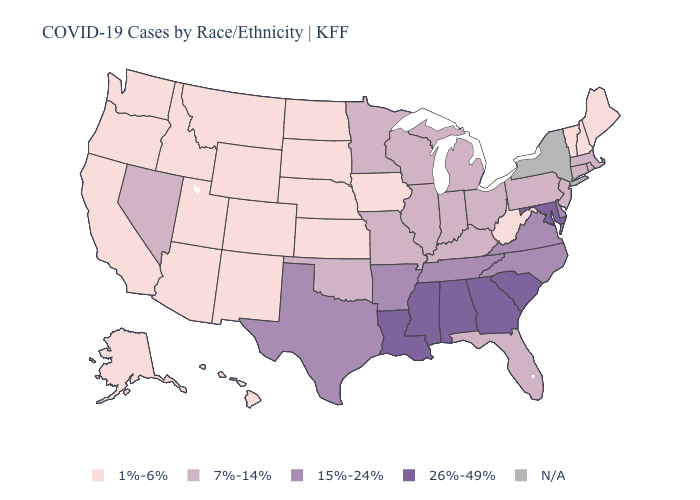What is the lowest value in the Northeast?
Concise answer only. 1%-6%. Does the map have missing data?
Give a very brief answer. Yes. Name the states that have a value in the range 26%-49%?
Quick response, please. Alabama, Georgia, Louisiana, Maryland, Mississippi, South Carolina. Name the states that have a value in the range 7%-14%?
Be succinct. Connecticut, Florida, Illinois, Indiana, Kentucky, Massachusetts, Michigan, Minnesota, Missouri, Nevada, New Jersey, Ohio, Oklahoma, Pennsylvania, Rhode Island, Wisconsin. Name the states that have a value in the range 15%-24%?
Answer briefly. Arkansas, Delaware, North Carolina, Tennessee, Texas, Virginia. Name the states that have a value in the range 15%-24%?
Short answer required. Arkansas, Delaware, North Carolina, Tennessee, Texas, Virginia. What is the value of Indiana?
Short answer required. 7%-14%. What is the value of Hawaii?
Quick response, please. 1%-6%. Does the first symbol in the legend represent the smallest category?
Short answer required. Yes. Name the states that have a value in the range 15%-24%?
Short answer required. Arkansas, Delaware, North Carolina, Tennessee, Texas, Virginia. Name the states that have a value in the range 1%-6%?
Write a very short answer. Alaska, Arizona, California, Colorado, Hawaii, Idaho, Iowa, Kansas, Maine, Montana, Nebraska, New Hampshire, New Mexico, North Dakota, Oregon, South Dakota, Utah, Vermont, Washington, West Virginia, Wyoming. What is the value of Wisconsin?
Answer briefly. 7%-14%. What is the lowest value in the USA?
Answer briefly. 1%-6%. Does Washington have the highest value in the West?
Quick response, please. No. 